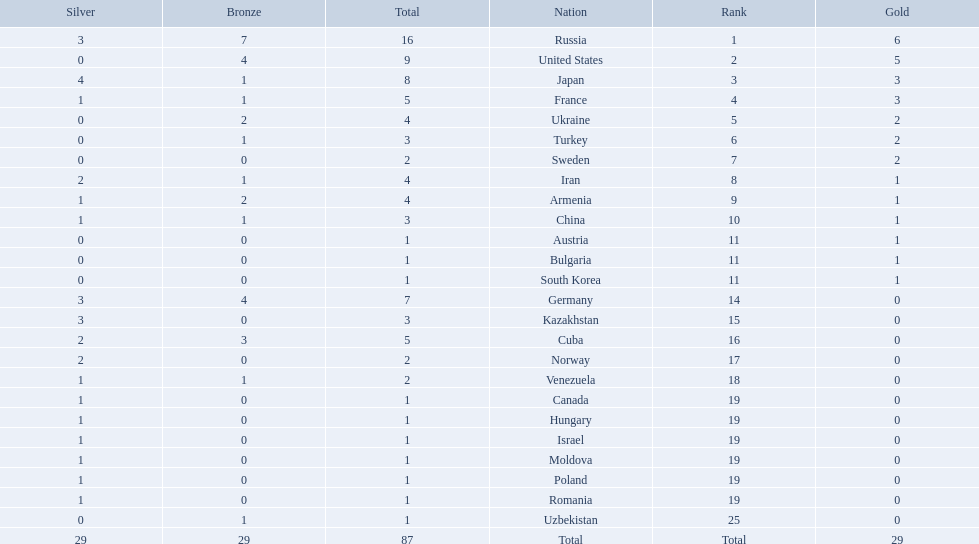How many countries competed? Israel. How many total medals did russia win? 16. What country won only 1 medal? Uzbekistan. 